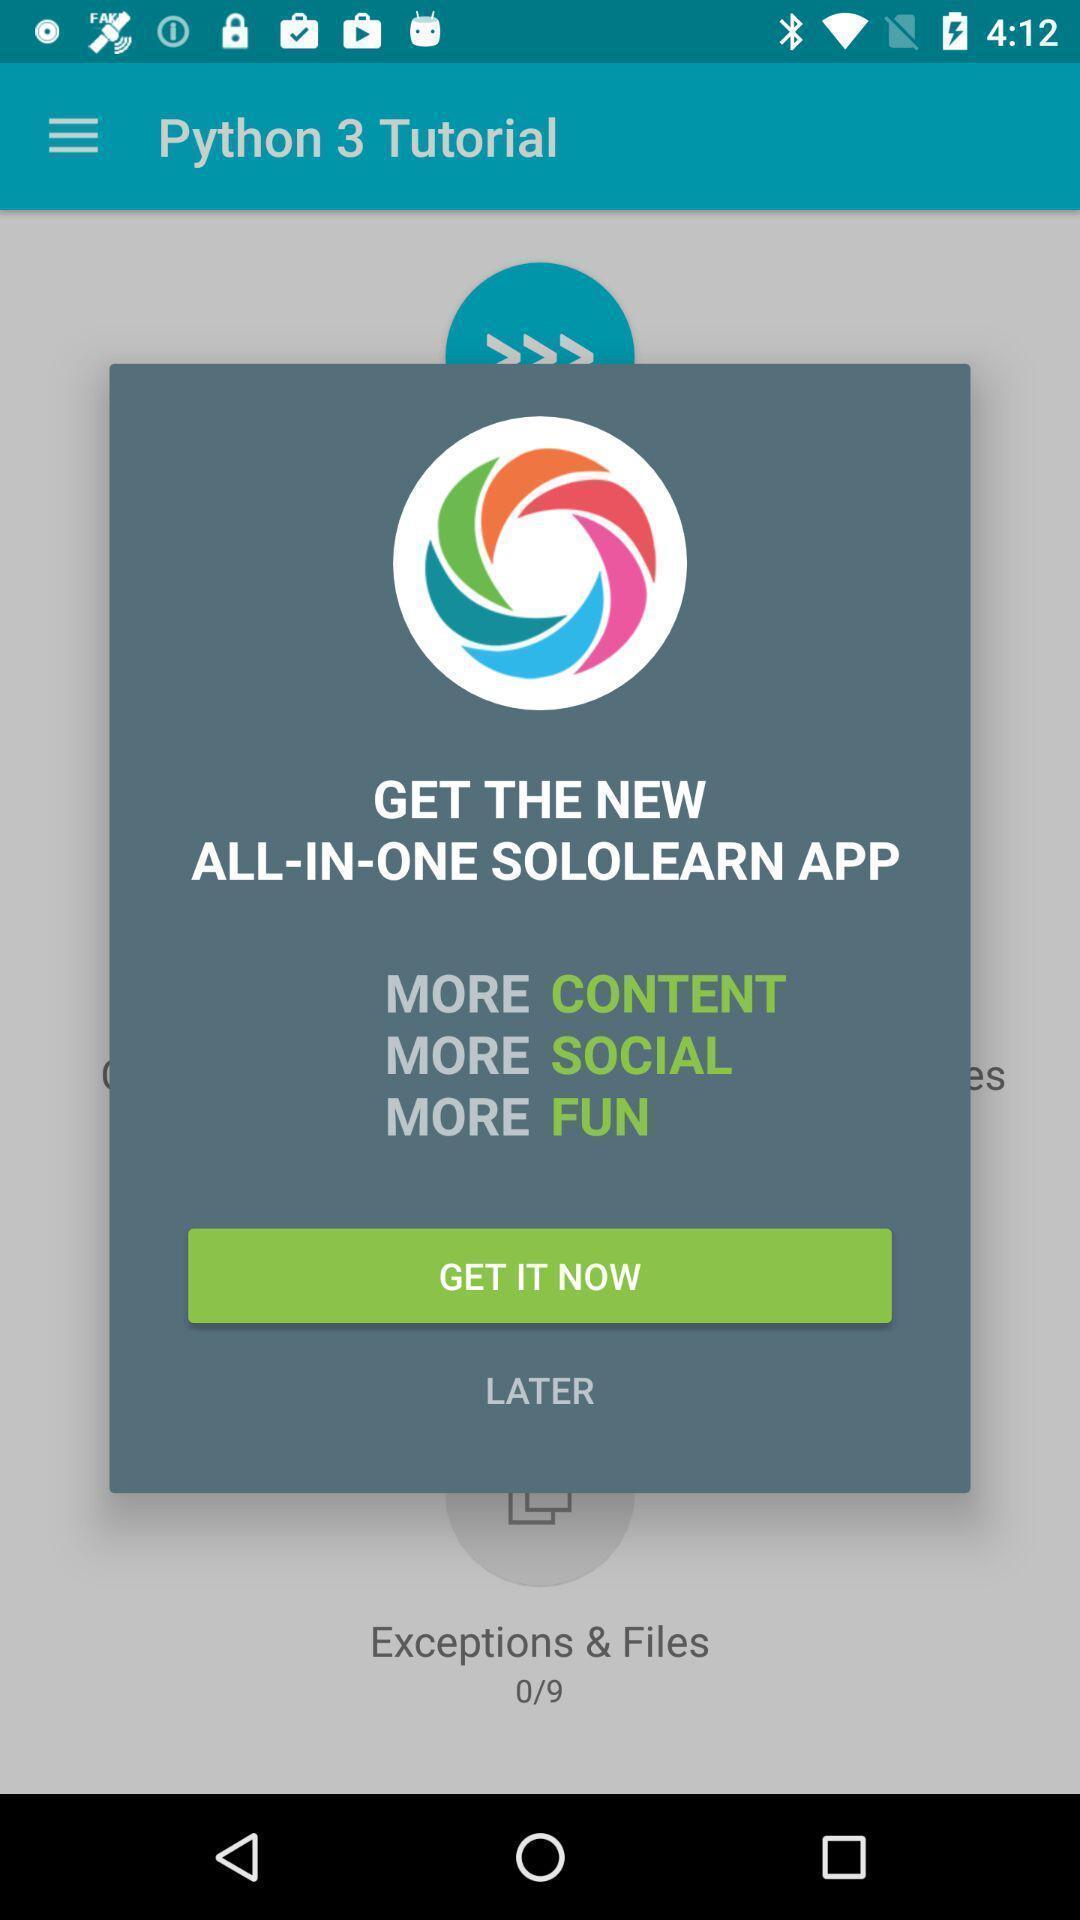Tell me about the visual elements in this screen capture. Pop-up with options in a code learning app. 